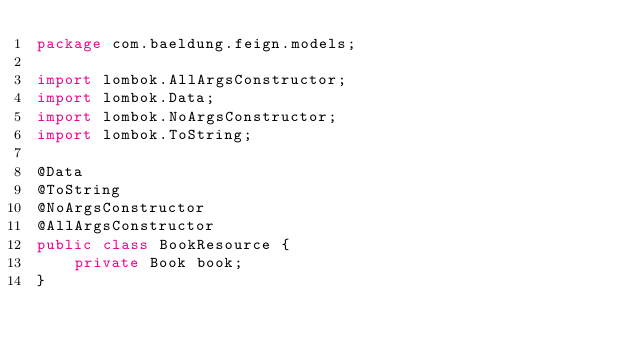<code> <loc_0><loc_0><loc_500><loc_500><_Java_>package com.baeldung.feign.models;

import lombok.AllArgsConstructor;
import lombok.Data;
import lombok.NoArgsConstructor;
import lombok.ToString;

@Data
@ToString
@NoArgsConstructor
@AllArgsConstructor
public class BookResource {
    private Book book;
}
</code> 